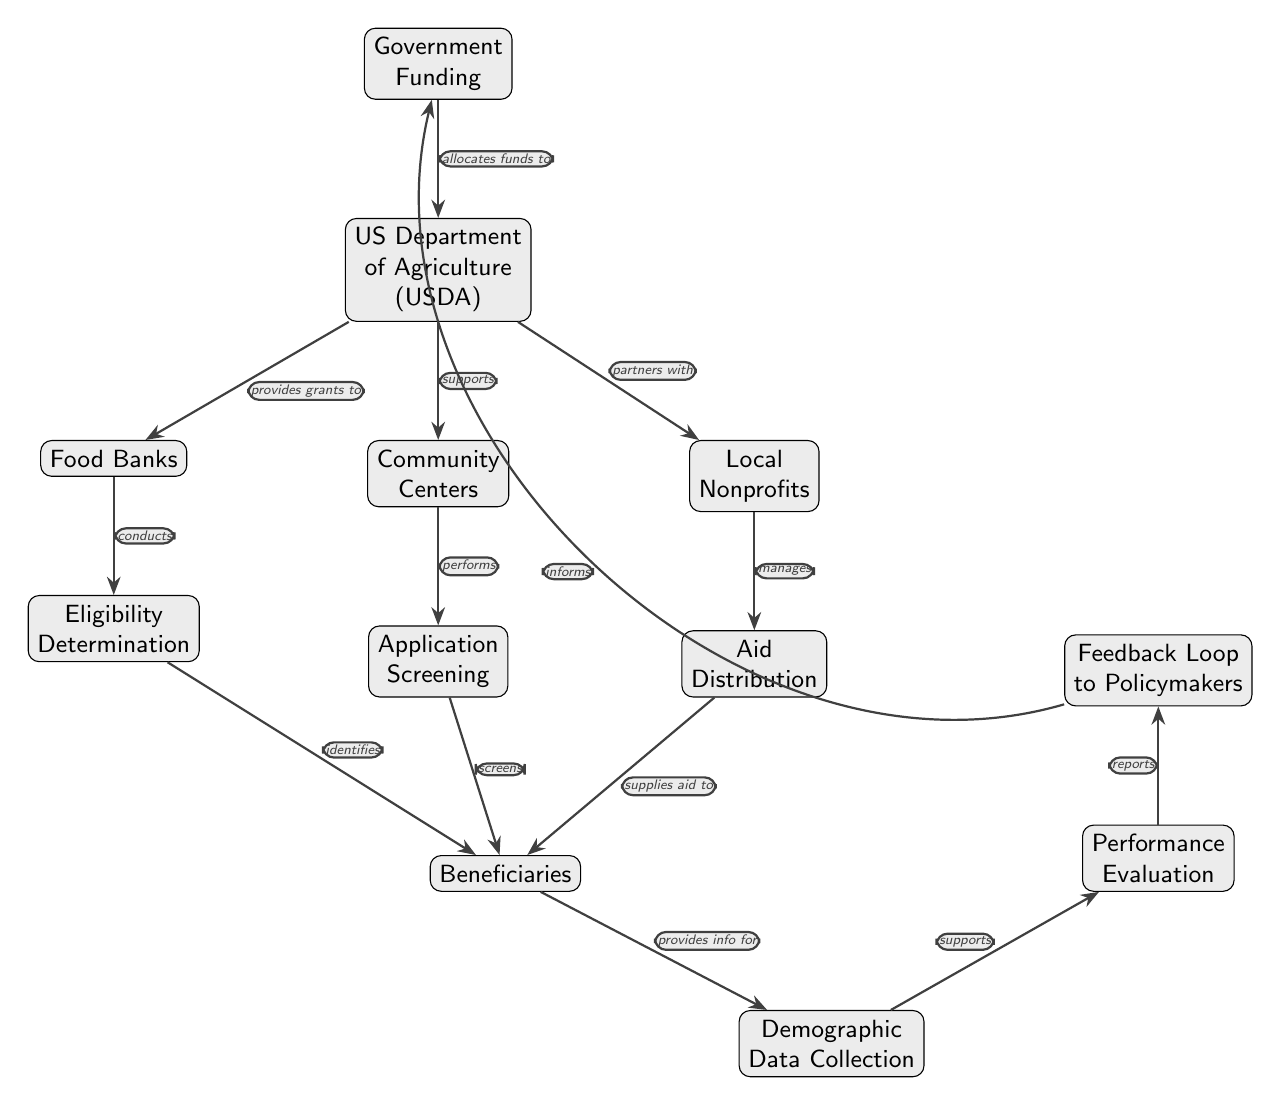What is the starting point of the flow in the diagram? The starting point of the flow is "Government Funding," which is the first node at the top of the diagram.
Answer: Government Funding How many organizations does the US Department of Agriculture (USDA) support? The USDA supports three organizations: Food Banks, Community Centers, and Local Nonprofits, represented as three nodes connected directly below it.
Answer: Three Which group conducts eligibility determination? The group that conducts eligibility determination is "Food Banks," as indicated by the directed edge leading from Food Banks to Eligibility Determination.
Answer: Food Banks What is the purpose of the feedback loop? The feedback loop serves to inform the "Government Funding" based on performance evaluation results, indicating it is used for data collection and improvement.
Answer: Informs Which node supplies aid to beneficiaries? The node that supplies aid to beneficiaries is "Aid Distribution," as it is connected to the Beneficiaries node, indicating the flow of aid.
Answer: Aid Distribution What do local nonprofits manage in the diagram? Local Nonprofits manage "Aid Distribution," as shown by the direct connection from Local Nonprofits to Aid Distribution.
Answer: Aid Distribution What is the function of demographic data collection? The function of demographic data collection is to support performance evaluation by providing information about the beneficiaries served, as indicated by the directed edge.
Answer: Supports How does performance evaluation interact with the flow? Performance evaluation interacts with the flow by receiving information from demographic data collection and then reporting back to policymakers via the feedback loop.
Answer: Reports Which node directly identifies beneficiaries? The nodes that directly identify beneficiaries are "Eligibility Determination" and "Application Screening," as they both connect to the Beneficiaries node independently.
Answer: Eligibility Determination and Application Screening 